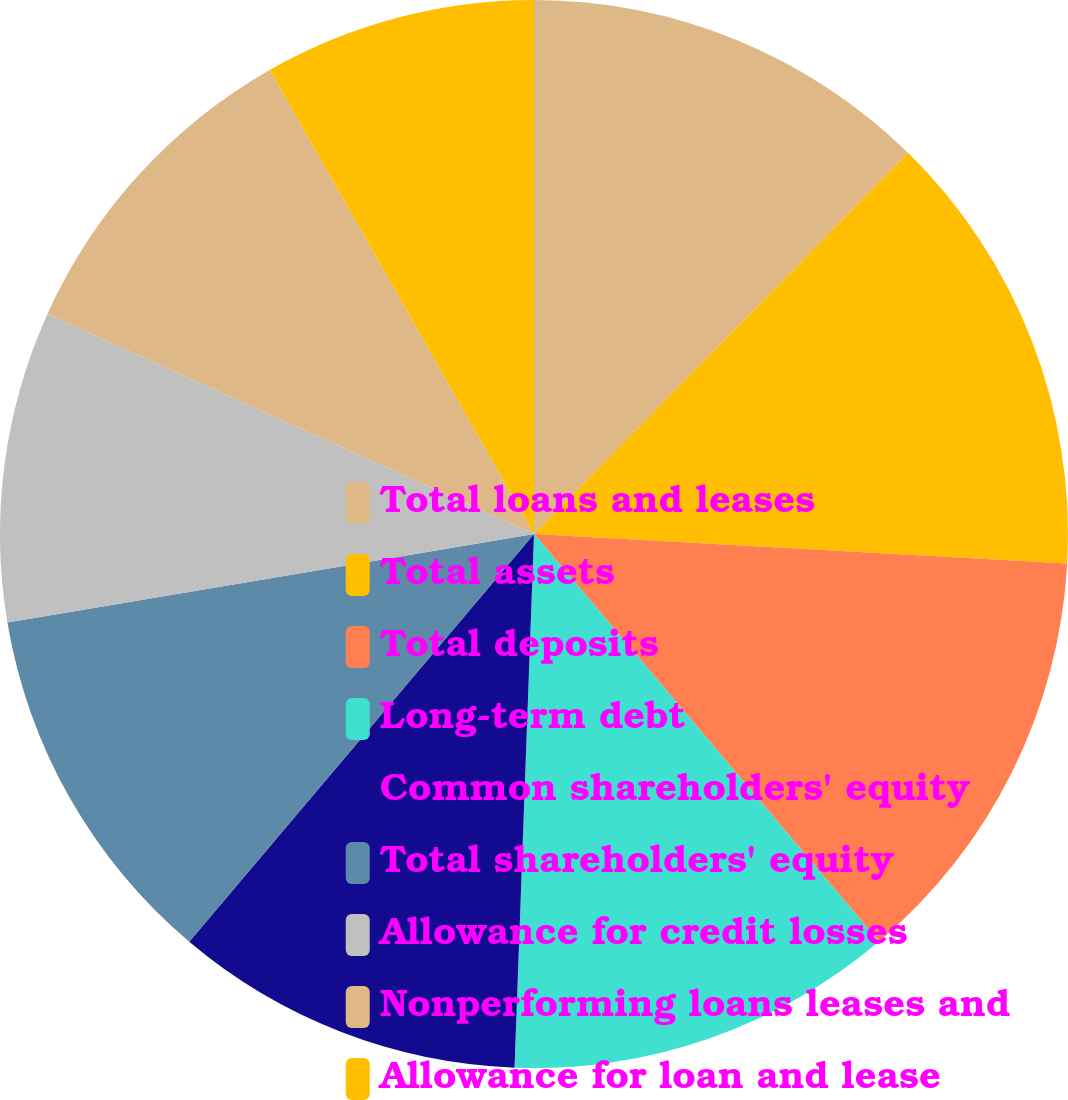<chart> <loc_0><loc_0><loc_500><loc_500><pie_chart><fcel>Total loans and leases<fcel>Total assets<fcel>Total deposits<fcel>Long-term debt<fcel>Common shareholders' equity<fcel>Total shareholders' equity<fcel>Allowance for credit losses<fcel>Nonperforming loans leases and<fcel>Allowance for loan and lease<nl><fcel>12.35%<fcel>13.53%<fcel>12.94%<fcel>11.76%<fcel>10.59%<fcel>11.18%<fcel>9.41%<fcel>10.0%<fcel>8.24%<nl></chart> 